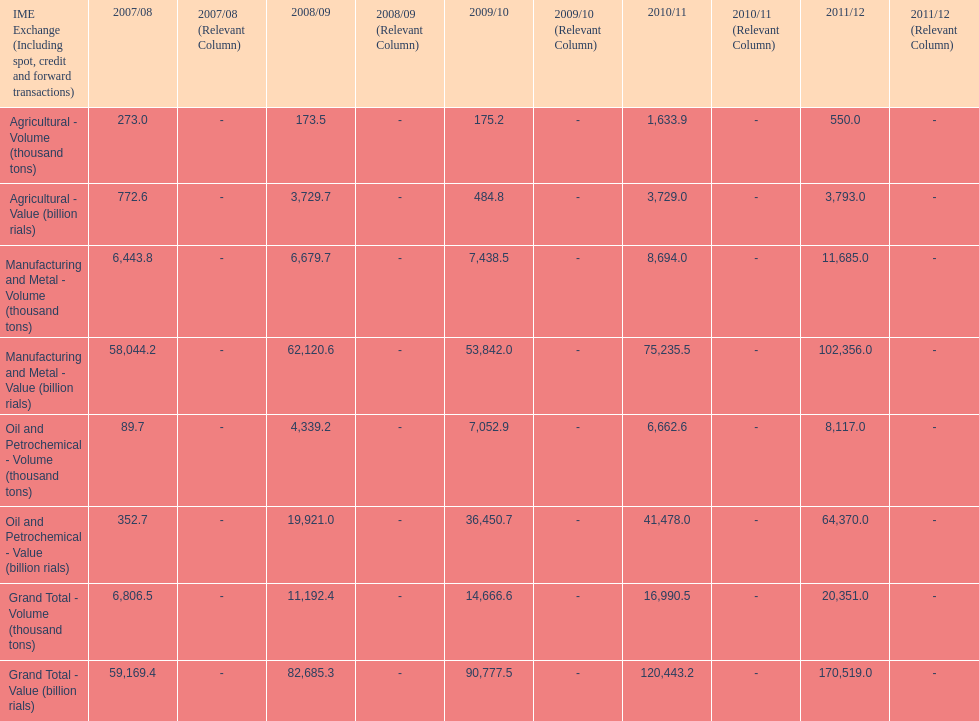Would you be able to parse every entry in this table? {'header': ['IME Exchange (Including spot, credit and forward transactions)', '2007/08', '2007/08 (Relevant Column)', '2008/09', '2008/09 (Relevant Column)', '2009/10', '2009/10 (Relevant Column)', '2010/11', '2010/11 (Relevant Column)', '2011/12', '2011/12 (Relevant Column)'], 'rows': [['Agricultural - Volume (thousand tons)', '273.0', '-', '173.5', '-', '175.2', '-', '1,633.9', '-', '550.0', '-'], ['Agricultural - Value (billion rials)', '772.6', '-', '3,729.7', '-', '484.8', '-', '3,729.0', '-', '3,793.0', '-'], ['Manufacturing and Metal - Volume (thousand tons)', '6,443.8', '-', '6,679.7', '-', '7,438.5', '-', '8,694.0', '-', '11,685.0', '-'], ['Manufacturing and Metal - Value (billion rials)', '58,044.2', '-', '62,120.6', '-', '53,842.0', '-', '75,235.5', '-', '102,356.0', '-'], ['Oil and Petrochemical - Volume (thousand tons)', '89.7', '-', '4,339.2', '-', '7,052.9', '-', '6,662.6', '-', '8,117.0', '-'], ['Oil and Petrochemical - Value (billion rials)', '352.7', '-', '19,921.0', '-', '36,450.7', '-', '41,478.0', '-', '64,370.0', '-'], ['Grand Total - Volume (thousand tons)', '6,806.5', '-', '11,192.4', '-', '14,666.6', '-', '16,990.5', '-', '20,351.0', '-'], ['Grand Total - Value (billion rials)', '59,169.4', '-', '82,685.3', '-', '90,777.5', '-', '120,443.2', '-', '170,519.0', '-']]} What year saw the greatest value for manufacturing and metal in iran? 2011/12. 